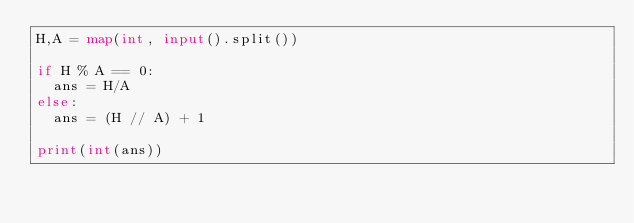<code> <loc_0><loc_0><loc_500><loc_500><_Python_>H,A = map(int, input().split())

if H % A == 0:
  ans = H/A
else:
  ans = (H // A) + 1

print(int(ans))</code> 